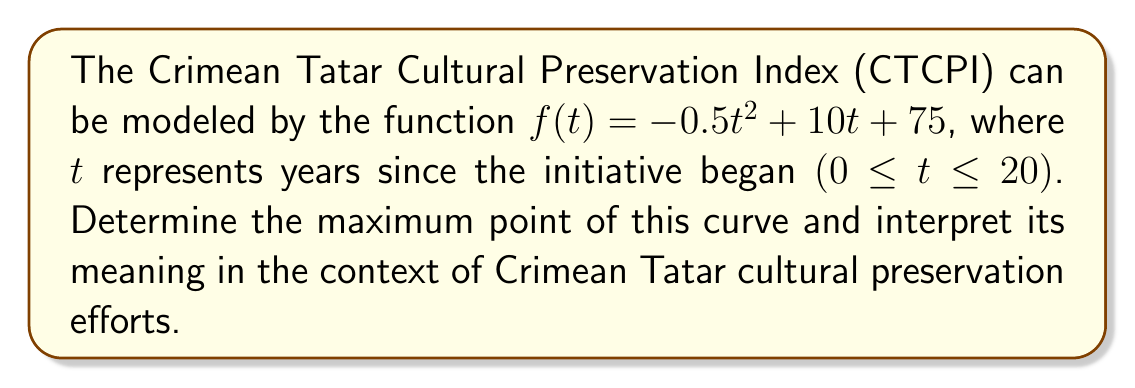Show me your answer to this math problem. To find the maximum point of the curve, we need to follow these steps:

1) Find the derivative of the function:
   $f'(t) = -t + 10$

2) Set the derivative equal to zero and solve for t:
   $f'(t) = 0$
   $-t + 10 = 0$
   $t = 10$

3) Verify it's a maximum by checking the second derivative:
   $f''(t) = -1 < 0$, confirming it's a maximum.

4) Calculate the y-coordinate by plugging t = 10 into the original function:
   $f(10) = -0.5(10)^2 + 10(10) + 75$
   $= -50 + 100 + 75 = 125$

5) Interpret the result:
   The maximum point occurs at (10, 125). This means that the Crimean Tatar Cultural Preservation Index reaches its peak value of 125 after 10 years of preservation efforts. After this point, the effectiveness of the efforts starts to decline, possibly due to saturation or diminishing returns.
Answer: (10, 125) 